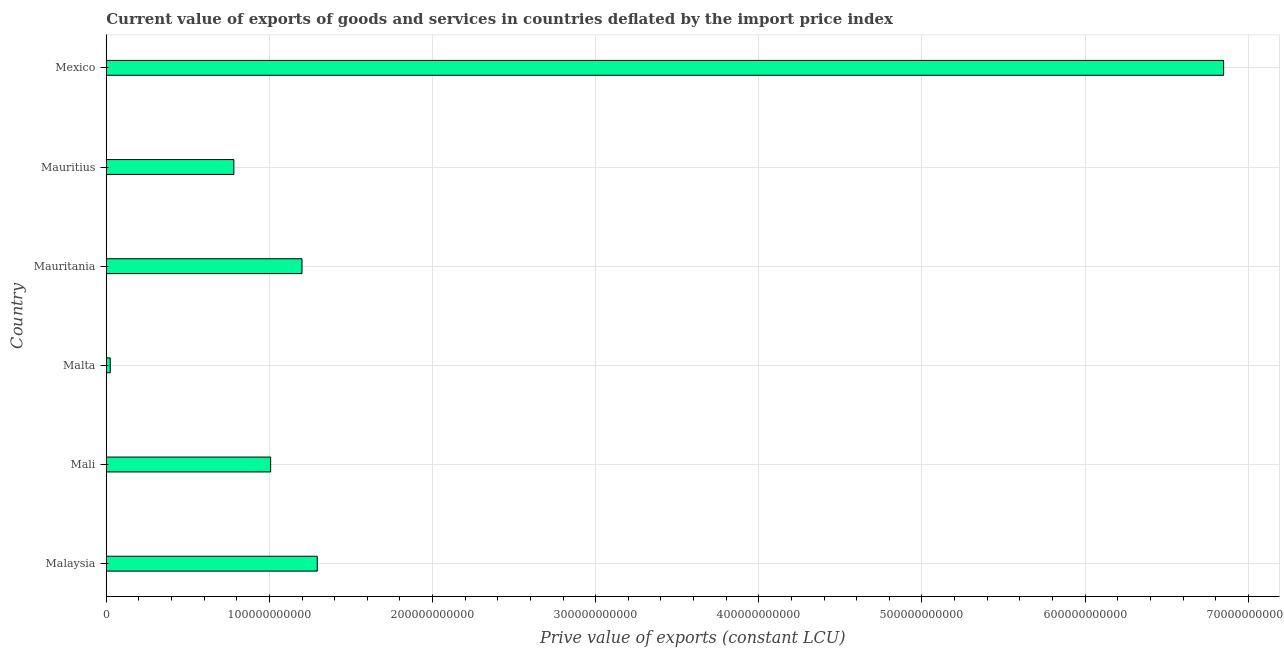Does the graph contain grids?
Offer a very short reply. Yes. What is the title of the graph?
Ensure brevity in your answer.  Current value of exports of goods and services in countries deflated by the import price index. What is the label or title of the X-axis?
Your response must be concise. Prive value of exports (constant LCU). What is the label or title of the Y-axis?
Give a very brief answer. Country. What is the price value of exports in Mauritius?
Your response must be concise. 7.82e+1. Across all countries, what is the maximum price value of exports?
Ensure brevity in your answer.  6.85e+11. Across all countries, what is the minimum price value of exports?
Provide a short and direct response. 2.46e+09. In which country was the price value of exports minimum?
Your answer should be compact. Malta. What is the sum of the price value of exports?
Provide a succinct answer. 1.12e+12. What is the difference between the price value of exports in Mali and Mauritius?
Keep it short and to the point. 2.25e+1. What is the average price value of exports per country?
Provide a succinct answer. 1.86e+11. What is the median price value of exports?
Offer a terse response. 1.10e+11. What is the ratio of the price value of exports in Malaysia to that in Mexico?
Offer a very short reply. 0.19. Is the difference between the price value of exports in Malaysia and Mauritius greater than the difference between any two countries?
Provide a short and direct response. No. What is the difference between the highest and the second highest price value of exports?
Your answer should be very brief. 5.56e+11. What is the difference between the highest and the lowest price value of exports?
Make the answer very short. 6.82e+11. In how many countries, is the price value of exports greater than the average price value of exports taken over all countries?
Provide a succinct answer. 1. How many bars are there?
Give a very brief answer. 6. Are all the bars in the graph horizontal?
Your answer should be very brief. Yes. How many countries are there in the graph?
Offer a terse response. 6. What is the difference between two consecutive major ticks on the X-axis?
Offer a terse response. 1.00e+11. What is the Prive value of exports (constant LCU) of Malaysia?
Your answer should be compact. 1.29e+11. What is the Prive value of exports (constant LCU) of Mali?
Ensure brevity in your answer.  1.01e+11. What is the Prive value of exports (constant LCU) of Malta?
Your response must be concise. 2.46e+09. What is the Prive value of exports (constant LCU) in Mauritania?
Offer a very short reply. 1.20e+11. What is the Prive value of exports (constant LCU) of Mauritius?
Your response must be concise. 7.82e+1. What is the Prive value of exports (constant LCU) in Mexico?
Your response must be concise. 6.85e+11. What is the difference between the Prive value of exports (constant LCU) in Malaysia and Mali?
Ensure brevity in your answer.  2.86e+1. What is the difference between the Prive value of exports (constant LCU) in Malaysia and Malta?
Provide a succinct answer. 1.27e+11. What is the difference between the Prive value of exports (constant LCU) in Malaysia and Mauritania?
Offer a very short reply. 9.37e+09. What is the difference between the Prive value of exports (constant LCU) in Malaysia and Mauritius?
Make the answer very short. 5.11e+1. What is the difference between the Prive value of exports (constant LCU) in Malaysia and Mexico?
Your answer should be compact. -5.56e+11. What is the difference between the Prive value of exports (constant LCU) in Mali and Malta?
Your response must be concise. 9.83e+1. What is the difference between the Prive value of exports (constant LCU) in Mali and Mauritania?
Your response must be concise. -1.92e+1. What is the difference between the Prive value of exports (constant LCU) in Mali and Mauritius?
Offer a terse response. 2.25e+1. What is the difference between the Prive value of exports (constant LCU) in Mali and Mexico?
Your response must be concise. -5.84e+11. What is the difference between the Prive value of exports (constant LCU) in Malta and Mauritania?
Make the answer very short. -1.18e+11. What is the difference between the Prive value of exports (constant LCU) in Malta and Mauritius?
Ensure brevity in your answer.  -7.58e+1. What is the difference between the Prive value of exports (constant LCU) in Malta and Mexico?
Give a very brief answer. -6.82e+11. What is the difference between the Prive value of exports (constant LCU) in Mauritania and Mauritius?
Make the answer very short. 4.18e+1. What is the difference between the Prive value of exports (constant LCU) in Mauritania and Mexico?
Make the answer very short. -5.65e+11. What is the difference between the Prive value of exports (constant LCU) in Mauritius and Mexico?
Offer a very short reply. -6.07e+11. What is the ratio of the Prive value of exports (constant LCU) in Malaysia to that in Mali?
Your answer should be very brief. 1.28. What is the ratio of the Prive value of exports (constant LCU) in Malaysia to that in Malta?
Offer a terse response. 52.48. What is the ratio of the Prive value of exports (constant LCU) in Malaysia to that in Mauritania?
Keep it short and to the point. 1.08. What is the ratio of the Prive value of exports (constant LCU) in Malaysia to that in Mauritius?
Keep it short and to the point. 1.65. What is the ratio of the Prive value of exports (constant LCU) in Malaysia to that in Mexico?
Your answer should be compact. 0.19. What is the ratio of the Prive value of exports (constant LCU) in Mali to that in Malta?
Your answer should be very brief. 40.88. What is the ratio of the Prive value of exports (constant LCU) in Mali to that in Mauritania?
Your answer should be compact. 0.84. What is the ratio of the Prive value of exports (constant LCU) in Mali to that in Mauritius?
Provide a succinct answer. 1.29. What is the ratio of the Prive value of exports (constant LCU) in Mali to that in Mexico?
Provide a succinct answer. 0.15. What is the ratio of the Prive value of exports (constant LCU) in Malta to that in Mauritania?
Provide a succinct answer. 0.02. What is the ratio of the Prive value of exports (constant LCU) in Malta to that in Mauritius?
Ensure brevity in your answer.  0.03. What is the ratio of the Prive value of exports (constant LCU) in Malta to that in Mexico?
Offer a very short reply. 0. What is the ratio of the Prive value of exports (constant LCU) in Mauritania to that in Mauritius?
Provide a succinct answer. 1.53. What is the ratio of the Prive value of exports (constant LCU) in Mauritania to that in Mexico?
Your answer should be very brief. 0.17. What is the ratio of the Prive value of exports (constant LCU) in Mauritius to that in Mexico?
Keep it short and to the point. 0.11. 